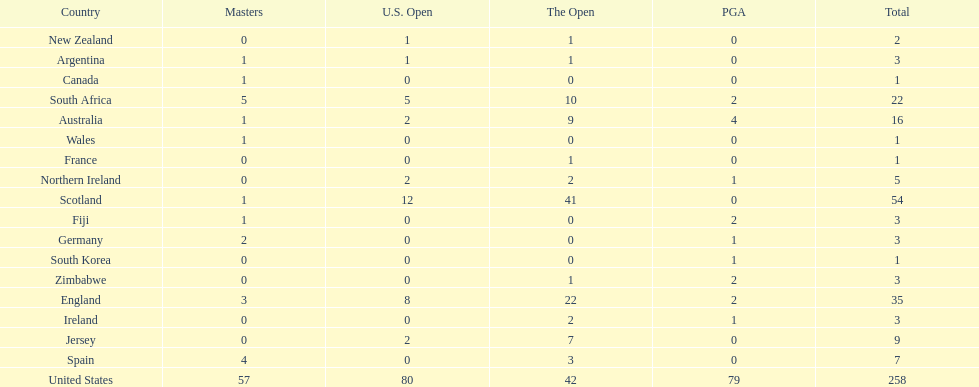Which african country has the least champion golfers according to this table? Zimbabwe. 